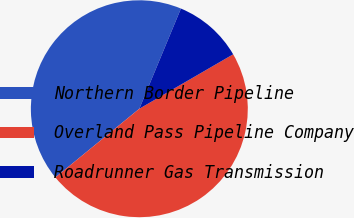Convert chart to OTSL. <chart><loc_0><loc_0><loc_500><loc_500><pie_chart><fcel>Northern Border Pipeline<fcel>Overland Pass Pipeline Company<fcel>Roadrunner Gas Transmission<nl><fcel>42.18%<fcel>47.45%<fcel>10.37%<nl></chart> 